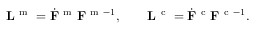Convert formula to latex. <formula><loc_0><loc_0><loc_500><loc_500>{ L } ^ { m } = \dot { F } ^ { m } { F } ^ { m - 1 } , \quad { L } ^ { c } = \dot { F } ^ { c } { F } ^ { c - 1 } .</formula> 